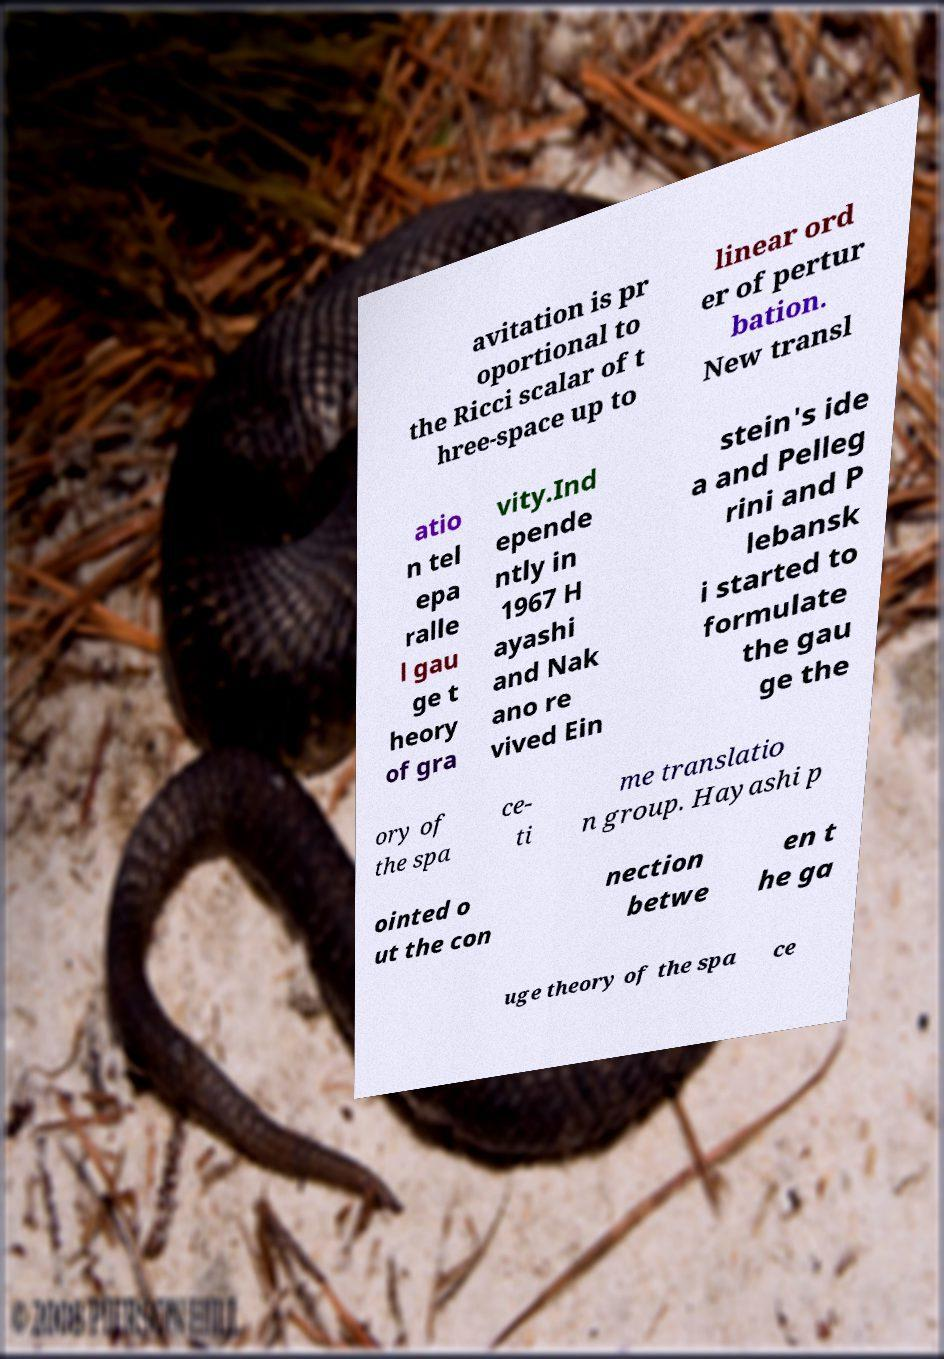For documentation purposes, I need the text within this image transcribed. Could you provide that? avitation is pr oportional to the Ricci scalar of t hree-space up to linear ord er of pertur bation. New transl atio n tel epa ralle l gau ge t heory of gra vity.Ind epende ntly in 1967 H ayashi and Nak ano re vived Ein stein's ide a and Pelleg rini and P lebansk i started to formulate the gau ge the ory of the spa ce- ti me translatio n group. Hayashi p ointed o ut the con nection betwe en t he ga uge theory of the spa ce 